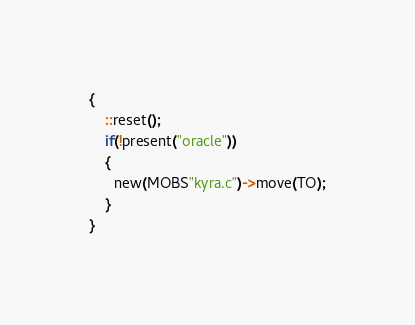Convert code to text. <code><loc_0><loc_0><loc_500><loc_500><_C_>{
    ::reset();
    if(!present("oracle"))
    {
      new(MOBS"kyra.c")->move(TO);
    }
}
</code> 